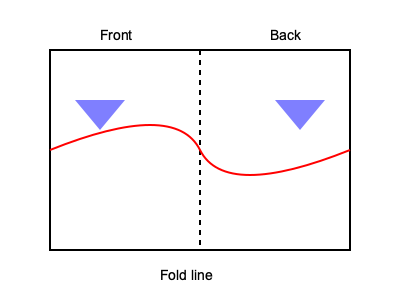In this 2D representation of a traditional Lithuanian folk costume, how would the triangular patterns on the front and back align when the garment is folded along the central dotted line to create a 3D form? To visualize the folding process and alignment of the triangular patterns, follow these steps:

1. Identify the key elements:
   - The dotted line in the center represents the fold line.
   - The left side of the diagram is the front of the garment.
   - The right side is the back of the garment.
   - There are two blue triangular patterns, one on each side.

2. Imagine folding the garment:
   - The right side (back) would fold over the left side (front) along the dotted line.

3. Analyze the position of the triangular patterns:
   - The triangle on the front is positioned slightly to the left of the fold line.
   - The triangle on the back is positioned slightly to the right of the fold line.
   - Both triangles are at the same height from the top of the garment.

4. Visualize the alignment after folding:
   - When folded, the back triangle would overlap the front triangle.
   - Due to their positions relative to the fold line, they would not align perfectly.
   - The triangles would create a slight offset pattern when the garment is folded.

5. Consider the 3D form:
   - In the folded 3D form, the triangles would appear on opposite sides of the garment.
   - They would be in approximately the same position vertically but slightly offset horizontally.

This offset alignment is common in traditional Lithuanian folk costumes, often creating intricate patterns when the garment is worn.
Answer: Slightly offset 